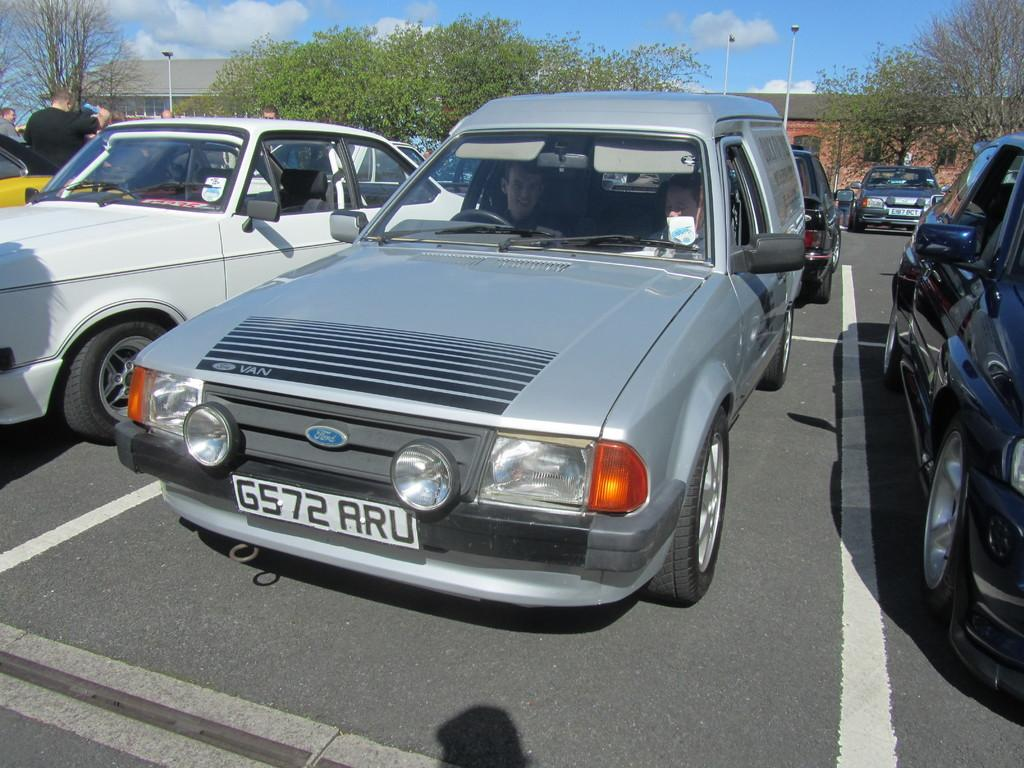What is the main subject of the image? There is a vehicle on the road in the image. What can be seen in the background of the image? In the background of the image, there are people, houses, electric poles, trees, and the sky. Can you describe the environment in the image? The image shows a road with a vehicle, surrounded by residential buildings, trees, and electric poles, with people and the sky visible in the background. What type of hearing can be observed in the image? There is no indication of a hearing in the image. 